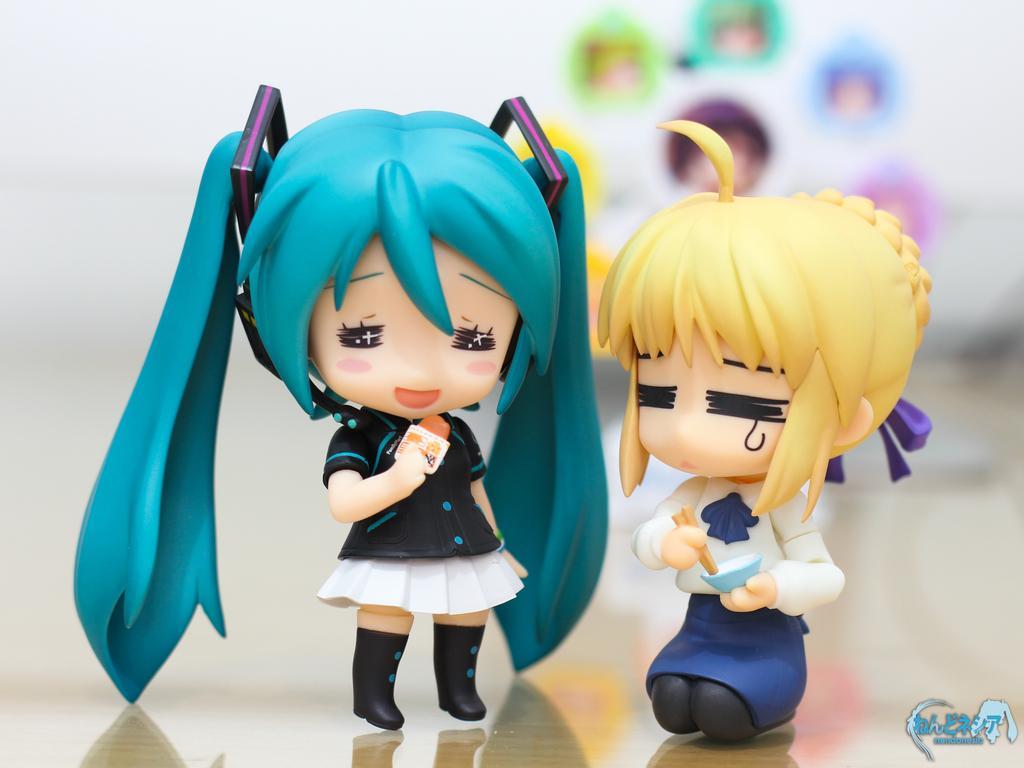Describe this image in one or two sentences. This image consists of two toys. They are in the middle. 